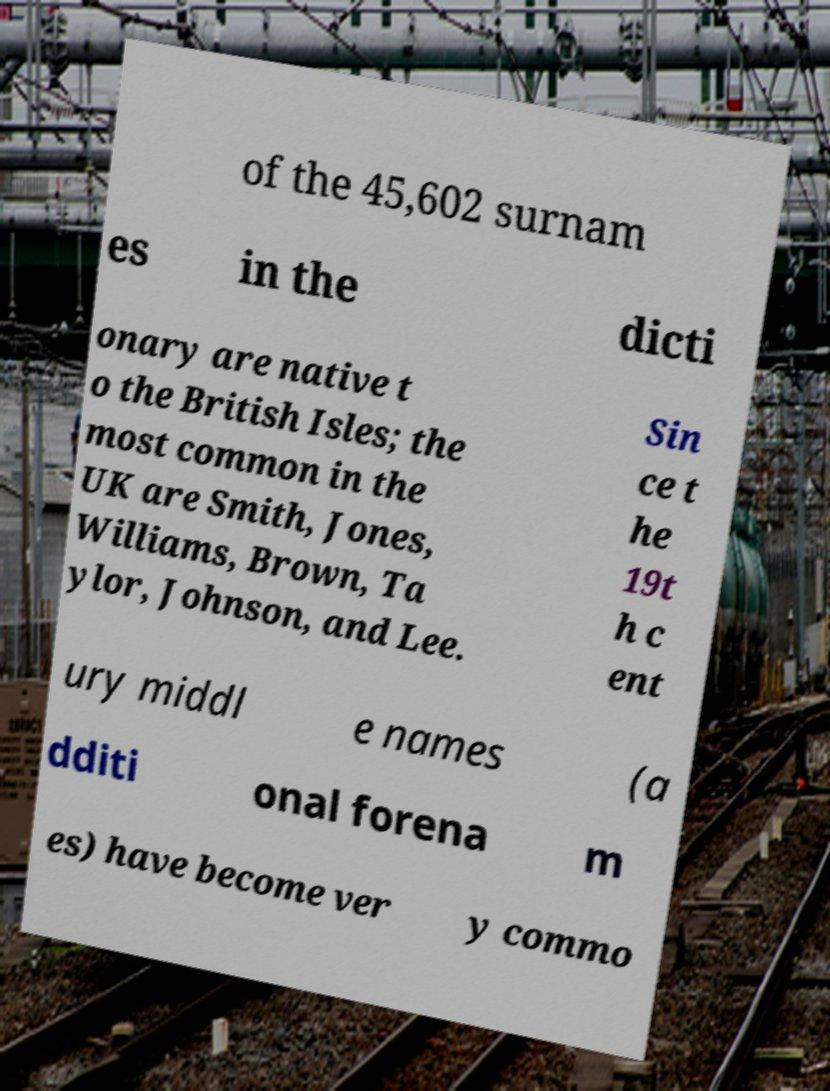For documentation purposes, I need the text within this image transcribed. Could you provide that? of the 45,602 surnam es in the dicti onary are native t o the British Isles; the most common in the UK are Smith, Jones, Williams, Brown, Ta ylor, Johnson, and Lee. Sin ce t he 19t h c ent ury middl e names (a dditi onal forena m es) have become ver y commo 